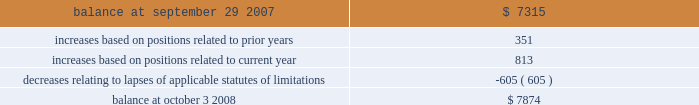Notes to consolidated financial statements 2014 ( continued ) a reconciliation of the beginning and ending amount of gross unrecognized tax benefits is as follows ( in thousands ) : .
The company 2019s major tax jurisdictions as of october 3 , 2008 for fin 48 are the u.s. , california , and iowa .
For the u.s. , the company has open tax years dating back to fiscal year 1998 due to the carryforward of tax attributes .
For california , the company has open tax years dating back to fiscal year 2002 due to the carryforward of tax attributes .
For iowa , the company has open tax years dating back to fiscal year 2002 due to the carryforward of tax attributes .
During the year ended october 3 , 2008 , the statute of limitations period expired relating to an unrecognized tax benefit .
The expiration of the statute of limitations period resulted in the recognition of $ 0.6 million of previously unrecognized tax benefit , which impacted the effective tax rate , and $ 0.5 million of accrued interest related to this tax position was reversed during the year .
Including this reversal , total year-to-date accrued interest related to the company 2019s unrecognized tax benefits was a benefit of $ 0.4 million .
10 .
Stockholders 2019 equity common stock the company is authorized to issue ( 1 ) 525000000 shares of common stock , par value $ 0.25 per share , and ( 2 ) 25000000 shares of preferred stock , without par value .
Holders of the company 2019s common stock are entitled to such dividends as may be declared by the company 2019s board of directors out of funds legally available for such purpose .
Dividends may not be paid on common stock unless all accrued dividends on preferred stock , if any , have been paid or declared and set aside .
In the event of the company 2019s liquidation , dissolution or winding up , the holders of common stock will be entitled to share pro rata in the assets remaining after payment to creditors and after payment of the liquidation preference plus any unpaid dividends to holders of any outstanding preferred stock .
Each holder of the company 2019s common stock is entitled to one vote for each such share outstanding in the holder 2019s name .
No holder of common stock is entitled to cumulate votes in voting for directors .
The company 2019s second amended and restated certificate of incorporation provides that , unless otherwise determined by the company 2019s board of directors , no holder of common stock has any preemptive right to purchase or subscribe for any stock of any class which the company may issue or sell .
In march 2007 , the company repurchased approximately 4.3 million of its common shares for $ 30.1 million as authorized by the company 2019s board of directors .
The company has no publicly disclosed stock repurchase plans .
At october 3 , 2008 , the company had 170322804 shares of common stock issued and 165591830 shares outstanding .
Preferred stock the company 2019s second amended and restated certificate of incorporation permits the company to issue up to 25000000 shares of preferred stock in one or more series and with rights and preferences that may be fixed or designated by the company 2019s board of directors without any further action by the company 2019s stockholders .
The designation , powers , preferences , rights and qualifications , limitations and restrictions of the preferred stock of each skyworks solutions , inc .
2008 annual report %%transmsg*** transmitting job : a51732 pcn : 099000000 ***%%pcmsg|103 |00005|yes|no|03/26/2009 13:34|0|0|page is valid , no graphics -- color : d| .
What is the total increase ross unrecognized tax benefits based on positions related to prior and current year? 
Computations: (351 + 813)
Answer: 1164.0. 